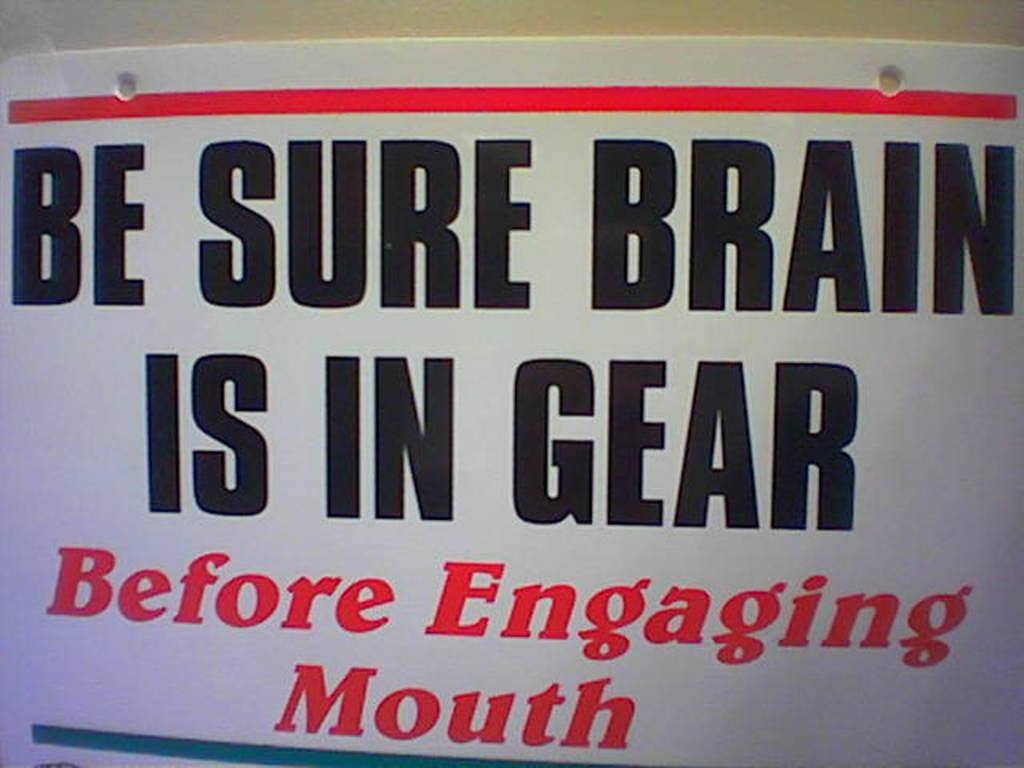<image>
Share a concise interpretation of the image provided. a sign that says be sure brain is in gear 